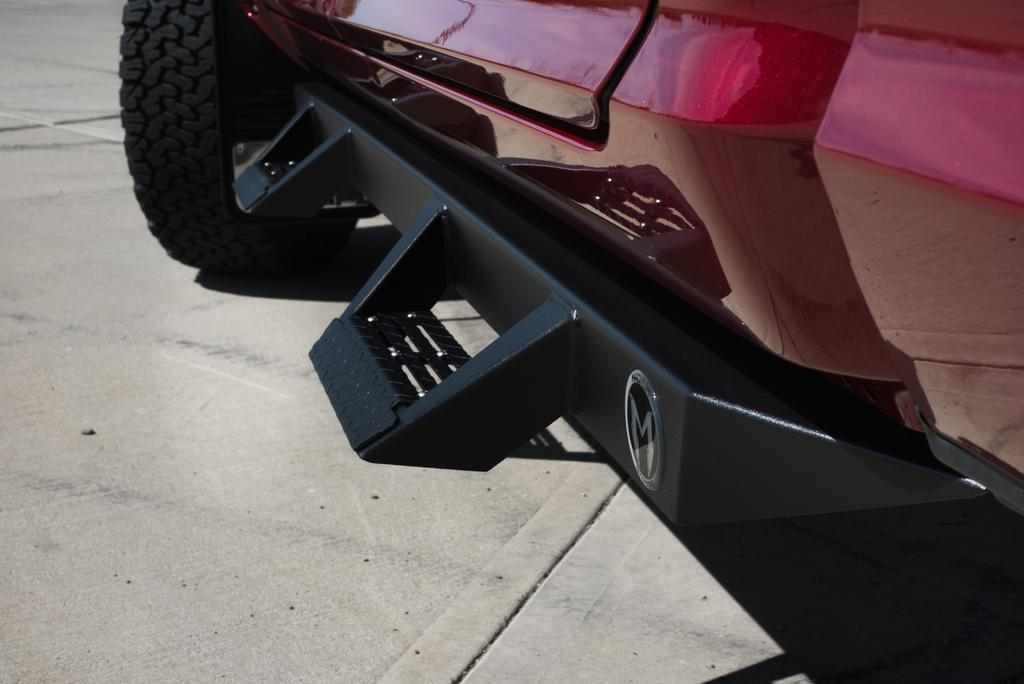What is the main subject of the image? There is a vehicle in the image. Which part of the vehicle is visible? The bumper part of the vehicle is visible. What can be seen on the ground near the vehicle? There is a black wheel on the road. Can you tell me how many roots are growing near the vehicle in the image? There are no roots visible in the image; it features a vehicle with a bumper and a black wheel on the road. Is there a beggar standing next to the vehicle in the image? There is no beggar present in the image; it only features a vehicle with a bumper and a black wheel on the road. 